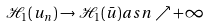Convert formula to latex. <formula><loc_0><loc_0><loc_500><loc_500>\mathcal { H } _ { 1 } ( u _ { n } ) \to \mathcal { H } _ { 1 } ( \bar { u } ) a s n \nearrow + \infty</formula> 